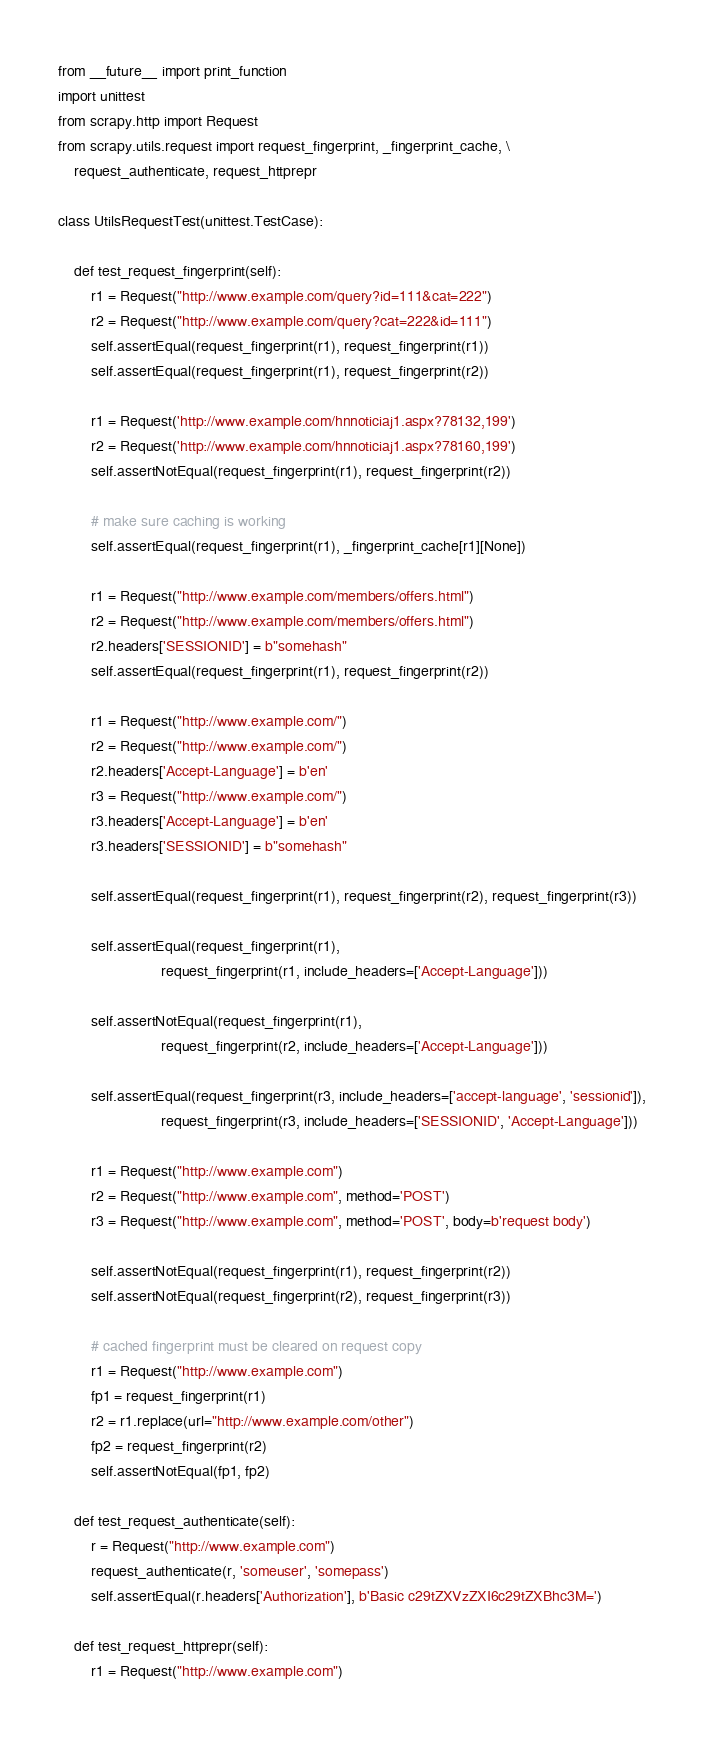<code> <loc_0><loc_0><loc_500><loc_500><_Python_>from __future__ import print_function
import unittest
from scrapy.http import Request
from scrapy.utils.request import request_fingerprint, _fingerprint_cache, \
    request_authenticate, request_httprepr

class UtilsRequestTest(unittest.TestCase):

    def test_request_fingerprint(self):
        r1 = Request("http://www.example.com/query?id=111&cat=222")
        r2 = Request("http://www.example.com/query?cat=222&id=111")
        self.assertEqual(request_fingerprint(r1), request_fingerprint(r1))
        self.assertEqual(request_fingerprint(r1), request_fingerprint(r2))

        r1 = Request('http://www.example.com/hnnoticiaj1.aspx?78132,199')
        r2 = Request('http://www.example.com/hnnoticiaj1.aspx?78160,199')
        self.assertNotEqual(request_fingerprint(r1), request_fingerprint(r2))

        # make sure caching is working
        self.assertEqual(request_fingerprint(r1), _fingerprint_cache[r1][None])

        r1 = Request("http://www.example.com/members/offers.html")
        r2 = Request("http://www.example.com/members/offers.html")
        r2.headers['SESSIONID'] = b"somehash"
        self.assertEqual(request_fingerprint(r1), request_fingerprint(r2))

        r1 = Request("http://www.example.com/")
        r2 = Request("http://www.example.com/")
        r2.headers['Accept-Language'] = b'en'
        r3 = Request("http://www.example.com/")
        r3.headers['Accept-Language'] = b'en'
        r3.headers['SESSIONID'] = b"somehash"

        self.assertEqual(request_fingerprint(r1), request_fingerprint(r2), request_fingerprint(r3))

        self.assertEqual(request_fingerprint(r1),
                         request_fingerprint(r1, include_headers=['Accept-Language']))

        self.assertNotEqual(request_fingerprint(r1),
                         request_fingerprint(r2, include_headers=['Accept-Language']))

        self.assertEqual(request_fingerprint(r3, include_headers=['accept-language', 'sessionid']),
                         request_fingerprint(r3, include_headers=['SESSIONID', 'Accept-Language']))

        r1 = Request("http://www.example.com")
        r2 = Request("http://www.example.com", method='POST')
        r3 = Request("http://www.example.com", method='POST', body=b'request body')

        self.assertNotEqual(request_fingerprint(r1), request_fingerprint(r2))
        self.assertNotEqual(request_fingerprint(r2), request_fingerprint(r3))

        # cached fingerprint must be cleared on request copy
        r1 = Request("http://www.example.com")
        fp1 = request_fingerprint(r1)
        r2 = r1.replace(url="http://www.example.com/other")
        fp2 = request_fingerprint(r2)
        self.assertNotEqual(fp1, fp2)

    def test_request_authenticate(self):
        r = Request("http://www.example.com")
        request_authenticate(r, 'someuser', 'somepass')
        self.assertEqual(r.headers['Authorization'], b'Basic c29tZXVzZXI6c29tZXBhc3M=')

    def test_request_httprepr(self):
        r1 = Request("http://www.example.com")</code> 